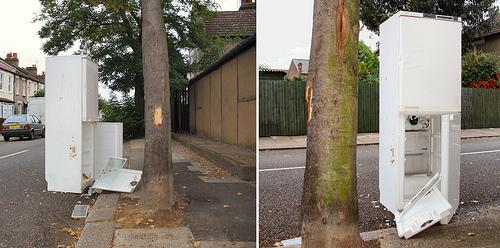Question: who is present?
Choices:
A. The family.
B. Nobody.
C. The spectators.
D. The workers.
Answer with the letter. Answer: B Question: how is the photo?
Choices:
A. Blurry.
B. Shadowy.
C. Bright.
D. Clear.
Answer with the letter. Answer: D Question: what color is the road?
Choices:
A. Grey.
B. Black.
C. White.
D. Brown.
Answer with the letter. Answer: A Question: what else is visible?
Choices:
A. A fence.
B. Trees.
C. Water.
D. Grass.
Answer with the letter. Answer: B Question: where was this photo taken?
Choices:
A. Columbus,OH.
B. Richmond,VA.
C. Brooklyn,NY.
D. On a street.
Answer with the letter. Answer: D 